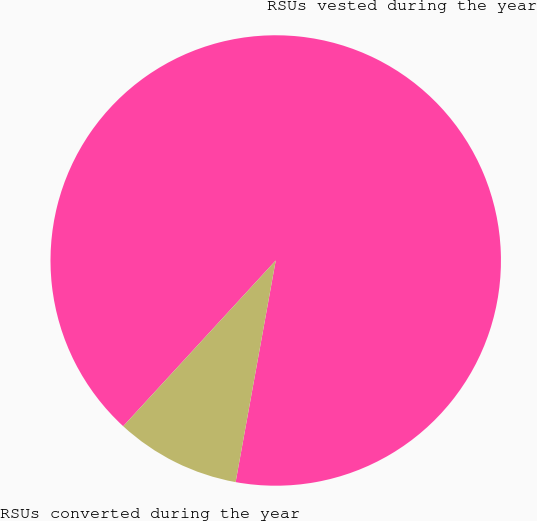<chart> <loc_0><loc_0><loc_500><loc_500><pie_chart><fcel>RSUs vested during the year<fcel>RSUs converted during the year<nl><fcel>91.01%<fcel>8.99%<nl></chart> 